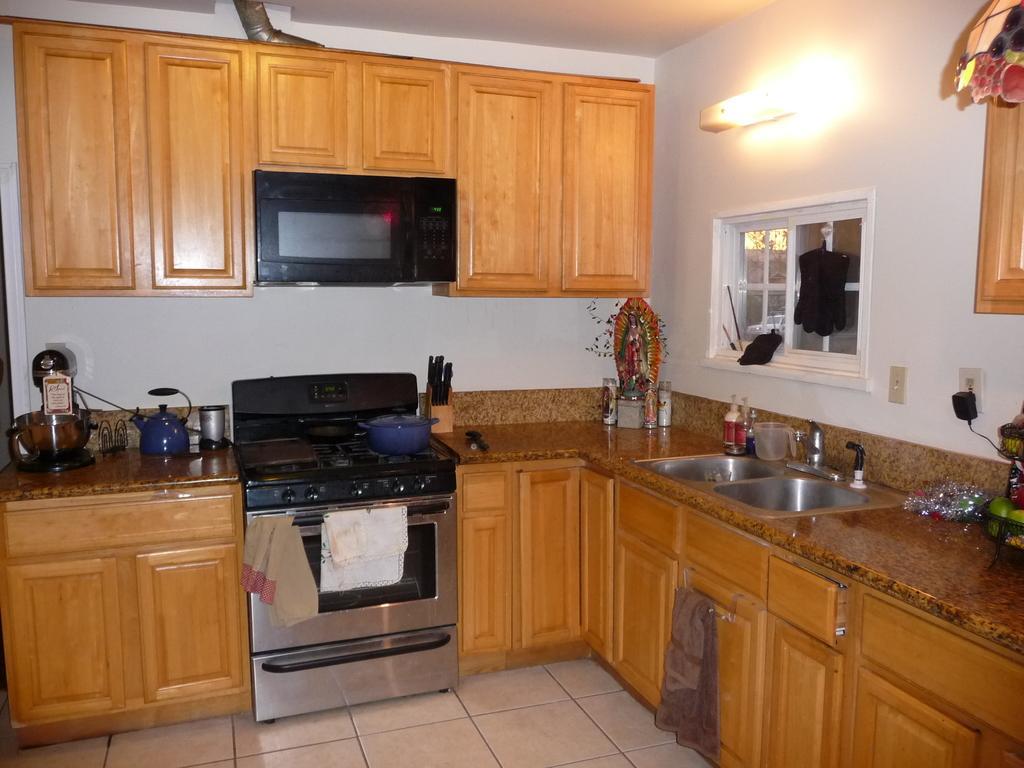Can you describe this image briefly? This is an inside picture of the room, we can see, cupboards, sinks, stove, bottles, sculptures, napkins and some other objects, also we can see the wall with a window, cupboards, switchboard and light. 